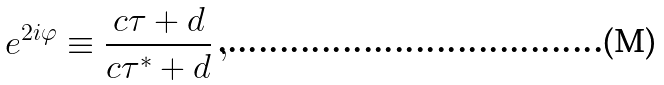Convert formula to latex. <formula><loc_0><loc_0><loc_500><loc_500>e ^ { 2 i \varphi } \equiv \frac { c \tau + d } { c \tau ^ { * } + d } \, ,</formula> 